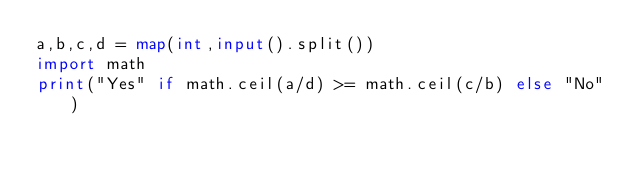<code> <loc_0><loc_0><loc_500><loc_500><_Python_>a,b,c,d = map(int,input().split())
import math
print("Yes" if math.ceil(a/d) >= math.ceil(c/b) else "No")</code> 